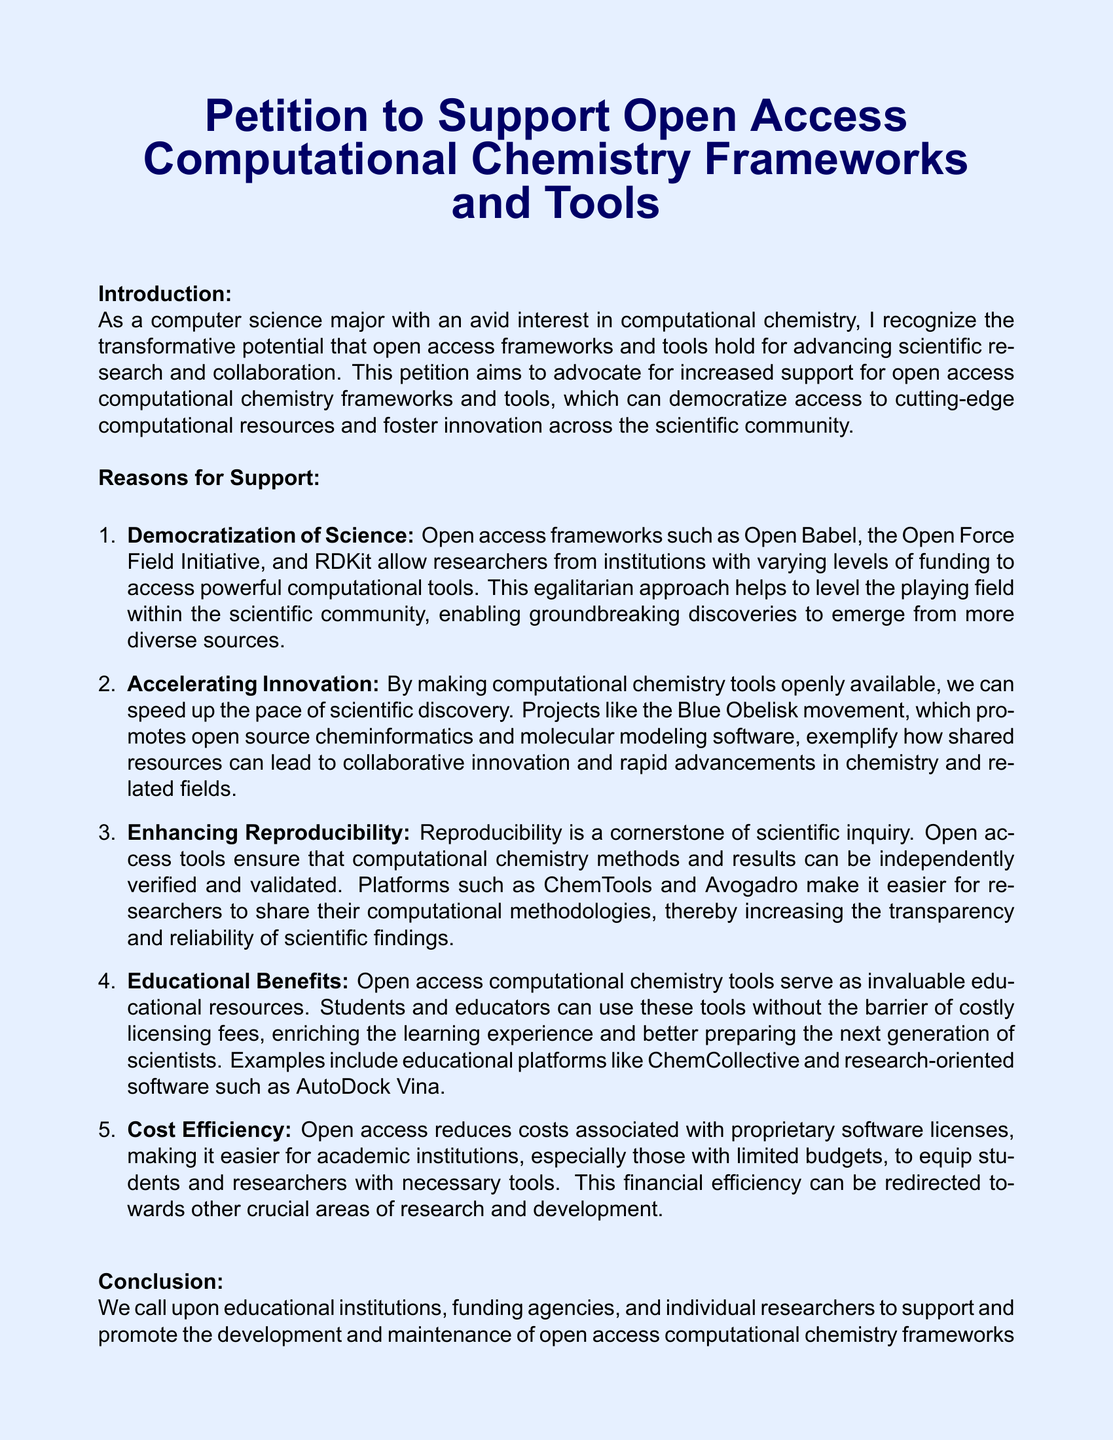What is the title of the petition? The title of the petition is stated in the document's header.
Answer: Petition to Support Open Access Computational Chemistry Frameworks and Tools Who initiated the petition? The petition is initiated by a computer science major with an interest in computational chemistry.
Answer: A computer science major Name one open access framework mentioned. The document lists examples of open access frameworks in the Reasons for Support section.
Answer: Open Babel What movement is mentioned as promoting open-source cheminformatics? The document specifically refers to a movement related to shared resources in the field of cheminformatics.
Answer: Blue Obelisk movement How many reasons for support are listed in the petition? The petition features a numbered list outlining several reasons for support.
Answer: Five What is one educational benefit mentioned? The document describes the role of open access tools in education.
Answer: Invaluable educational resources What is being called upon educational institutions to do? The document includes a call to action addressed to stakeholders in the educational sector.
Answer: Support and promote What color is used for the document's background? The background color is specified at the beginning of the document.
Answer: Light blue What is the purpose of signatures in the petition? The signatures serve as a demonstration of commitment by supporters.
Answer: Demonstrate their commitment 